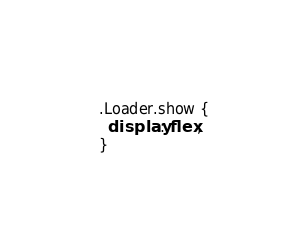Convert code to text. <code><loc_0><loc_0><loc_500><loc_500><_CSS_>
.Loader.show {
  display: flex;
}</code> 